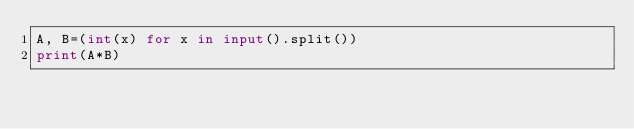Convert code to text. <code><loc_0><loc_0><loc_500><loc_500><_Python_>A, B=(int(x) for x in input().split())
print(A*B)</code> 